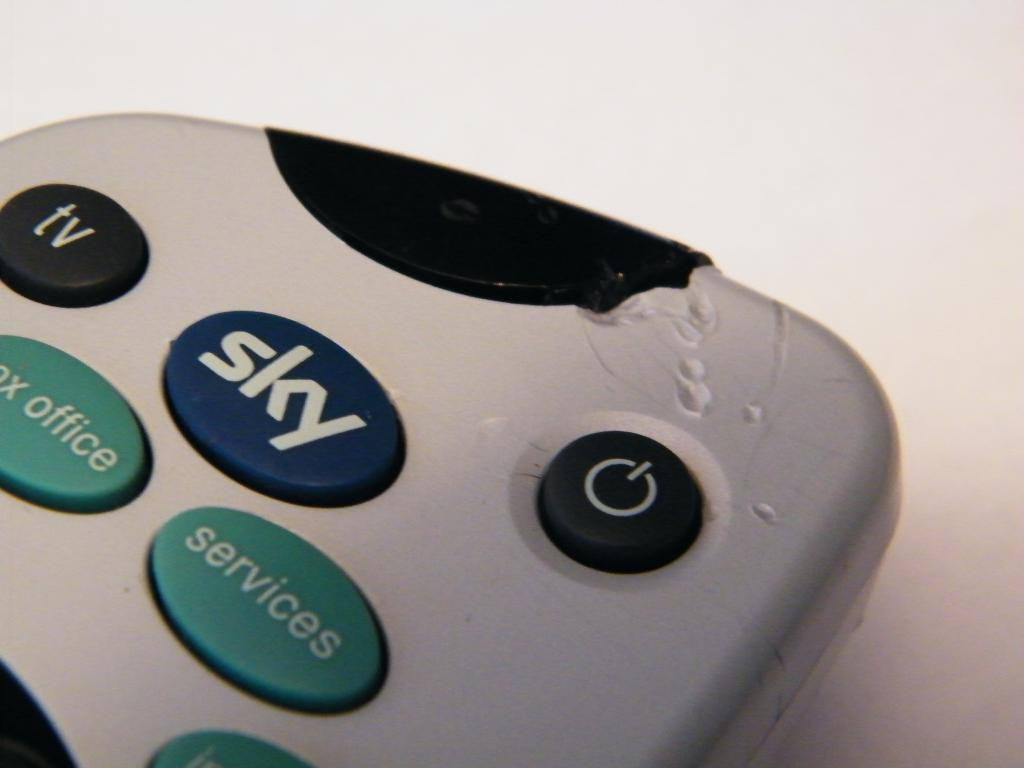<image>
Relay a brief, clear account of the picture shown. The top part of a Sky tuner remote that appears to have chew marks. 